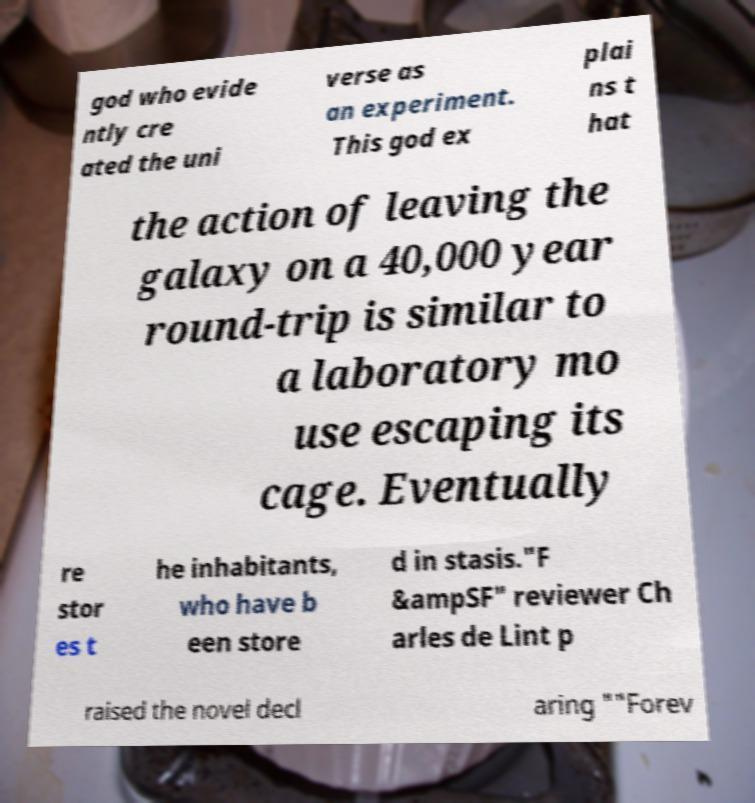What messages or text are displayed in this image? I need them in a readable, typed format. god who evide ntly cre ated the uni verse as an experiment. This god ex plai ns t hat the action of leaving the galaxy on a 40,000 year round-trip is similar to a laboratory mo use escaping its cage. Eventually re stor es t he inhabitants, who have b een store d in stasis."F &ampSF" reviewer Ch arles de Lint p raised the novel decl aring ""Forev 